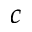Convert formula to latex. <formula><loc_0><loc_0><loc_500><loc_500>c</formula> 